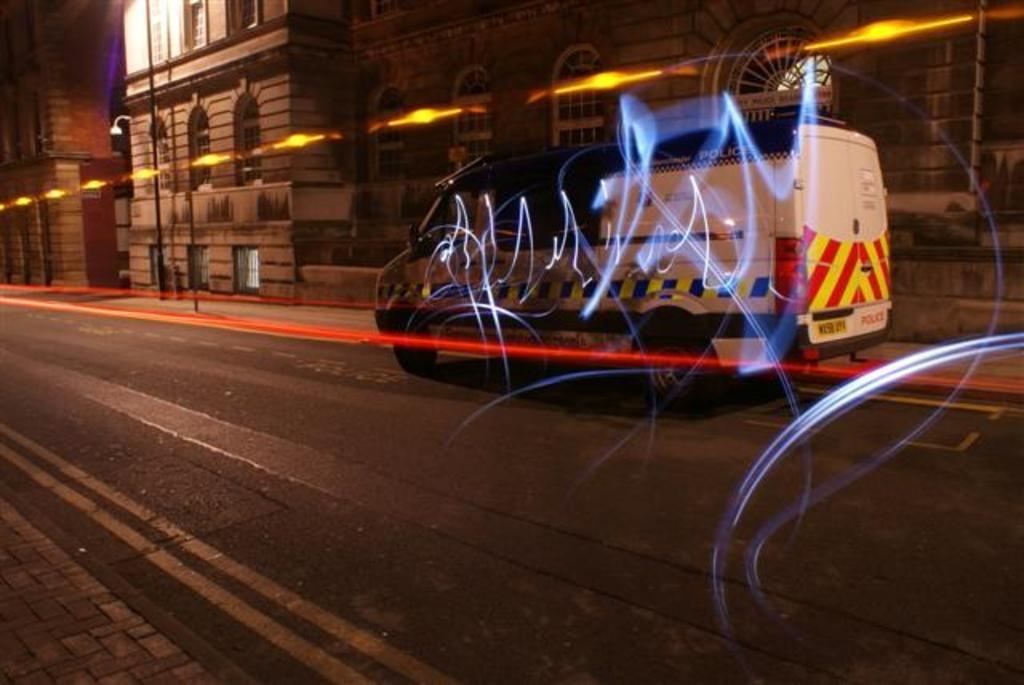What is the main feature of the image? There is a road in the image. What vehicle can be seen on the road? A van is present on the road. What can be seen in the image besides the road and the van? There are lights visible in the image, as well as buildings and a pole in the background. Can you hear the baby laughing or crying in the image? There is no baby present in the image, so it is not possible to hear any laughter or crying. 